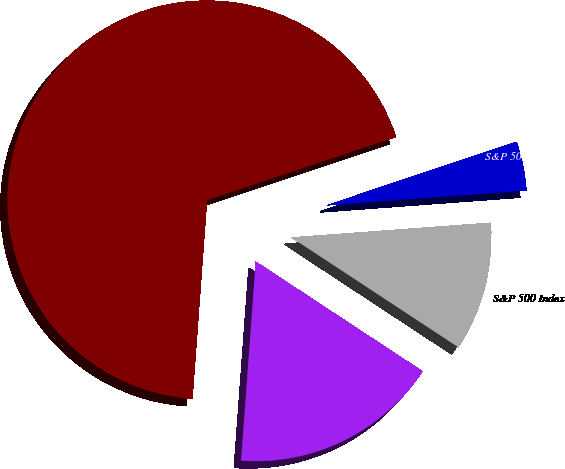Convert chart. <chart><loc_0><loc_0><loc_500><loc_500><pie_chart><fcel>Company / Index<fcel>Teleflex Incorporated<fcel>S&P 500 Index<fcel>S&P 500 Healthcare Equipment &<nl><fcel>68.7%<fcel>16.91%<fcel>10.43%<fcel>3.96%<nl></chart> 